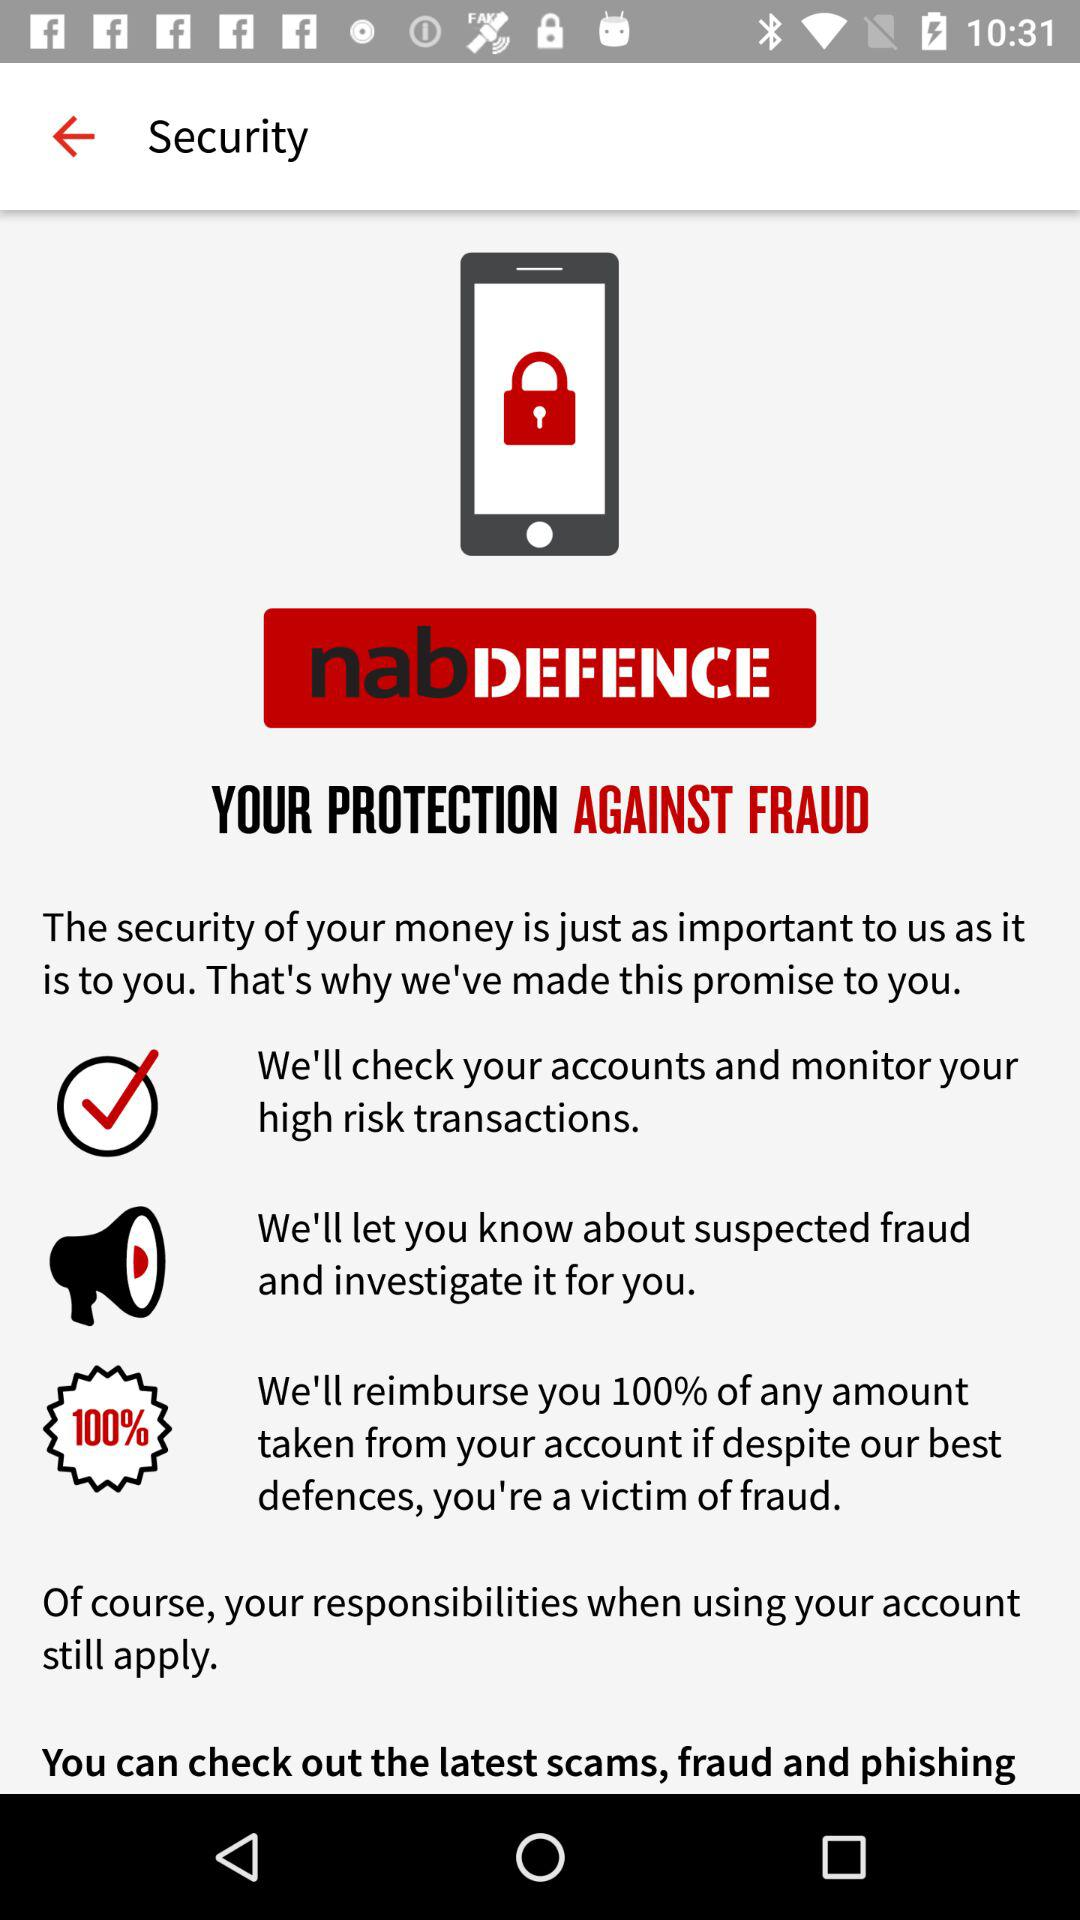What is the name of the application? The name of the application is "nab". 